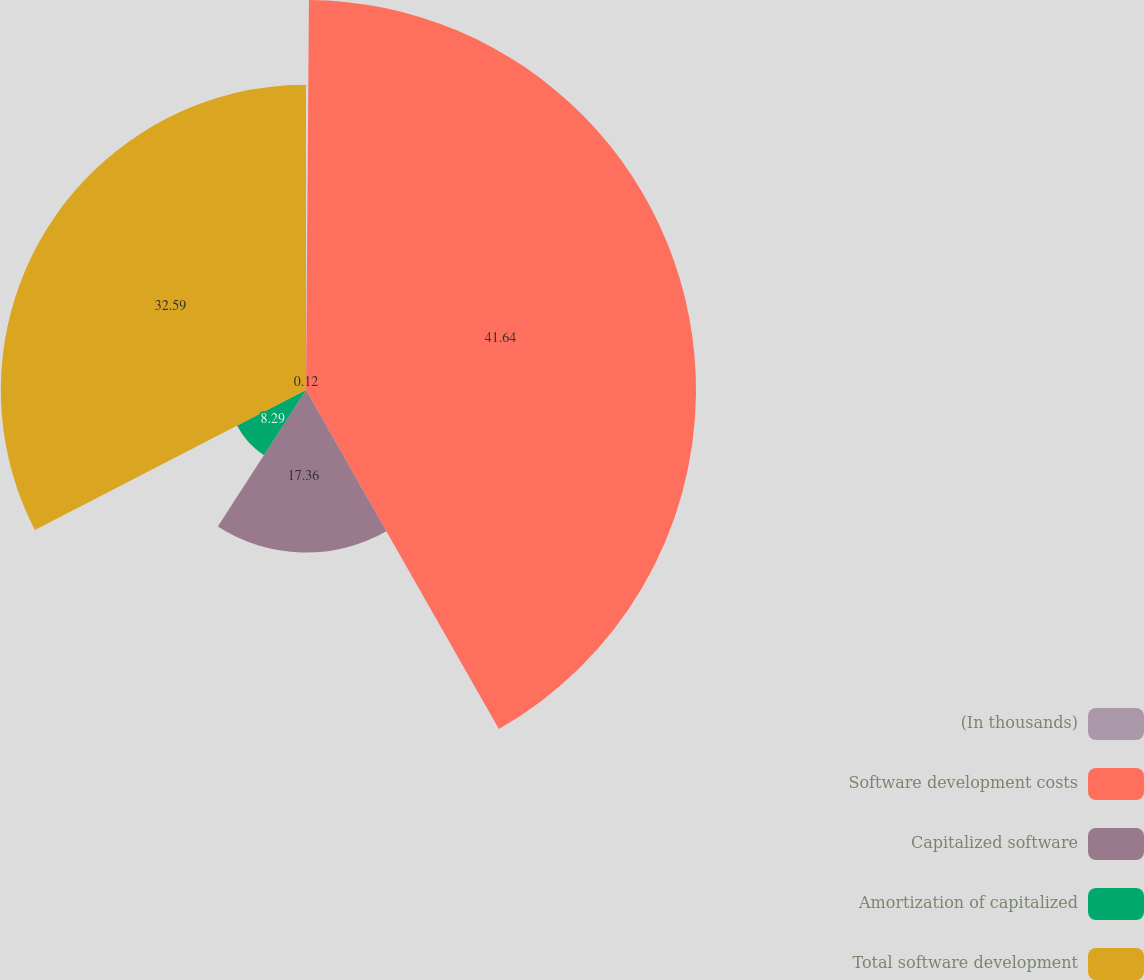Convert chart. <chart><loc_0><loc_0><loc_500><loc_500><pie_chart><fcel>(In thousands)<fcel>Software development costs<fcel>Capitalized software<fcel>Amortization of capitalized<fcel>Total software development<nl><fcel>0.12%<fcel>41.65%<fcel>17.36%<fcel>8.29%<fcel>32.59%<nl></chart> 